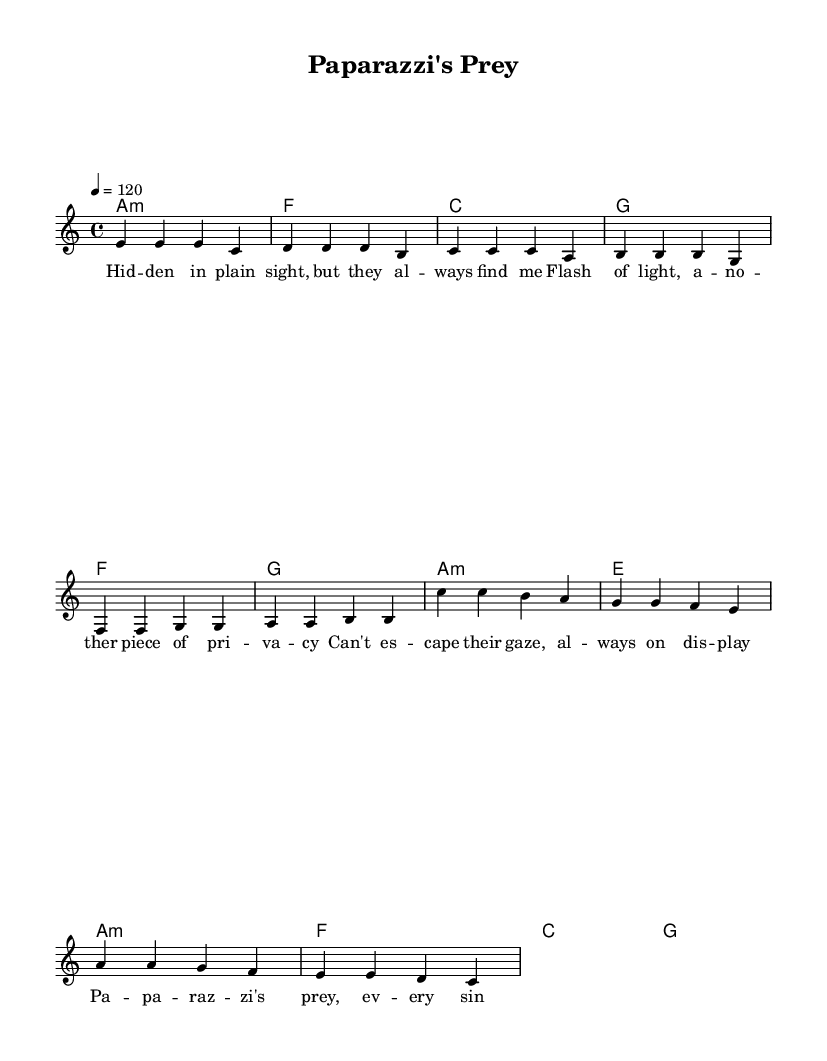What is the key signature of this music? The key signature is A minor, which has no sharps or flats.
Answer: A minor What is the time signature of this piece? The time signature is found near the beginning of the score, indicating the rhythm. In this case, it shows four beats per measure.
Answer: 4/4 What is the tempo marking of the piece? The tempo marking is indicated numerically, showing how many beats occur in a minute. Here, it is set to 120 beats per minute.
Answer: 120 How many measures are there in the melody? By counting the measures indicated in the melody section, we determine the total number. There are 12 measures present.
Answer: 12 What type of chord is used in the first measure of the verse? The first measure shows "a1:m," which designates an A minor chord. This indicates its quality as a minor triad.
Answer: A minor In which section does the phrase "no place left to hide" appear? By reviewing the lyrics and matching them with their respective sections, we see that this phrase is in the Verse section.
Answer: Verse Which musical section features the chord "g"? Assessing the chord progression, we see the appearance of the "g" chord in both the Verse and Chorus sections. However, it first appears in the Verse.
Answer: Verse 